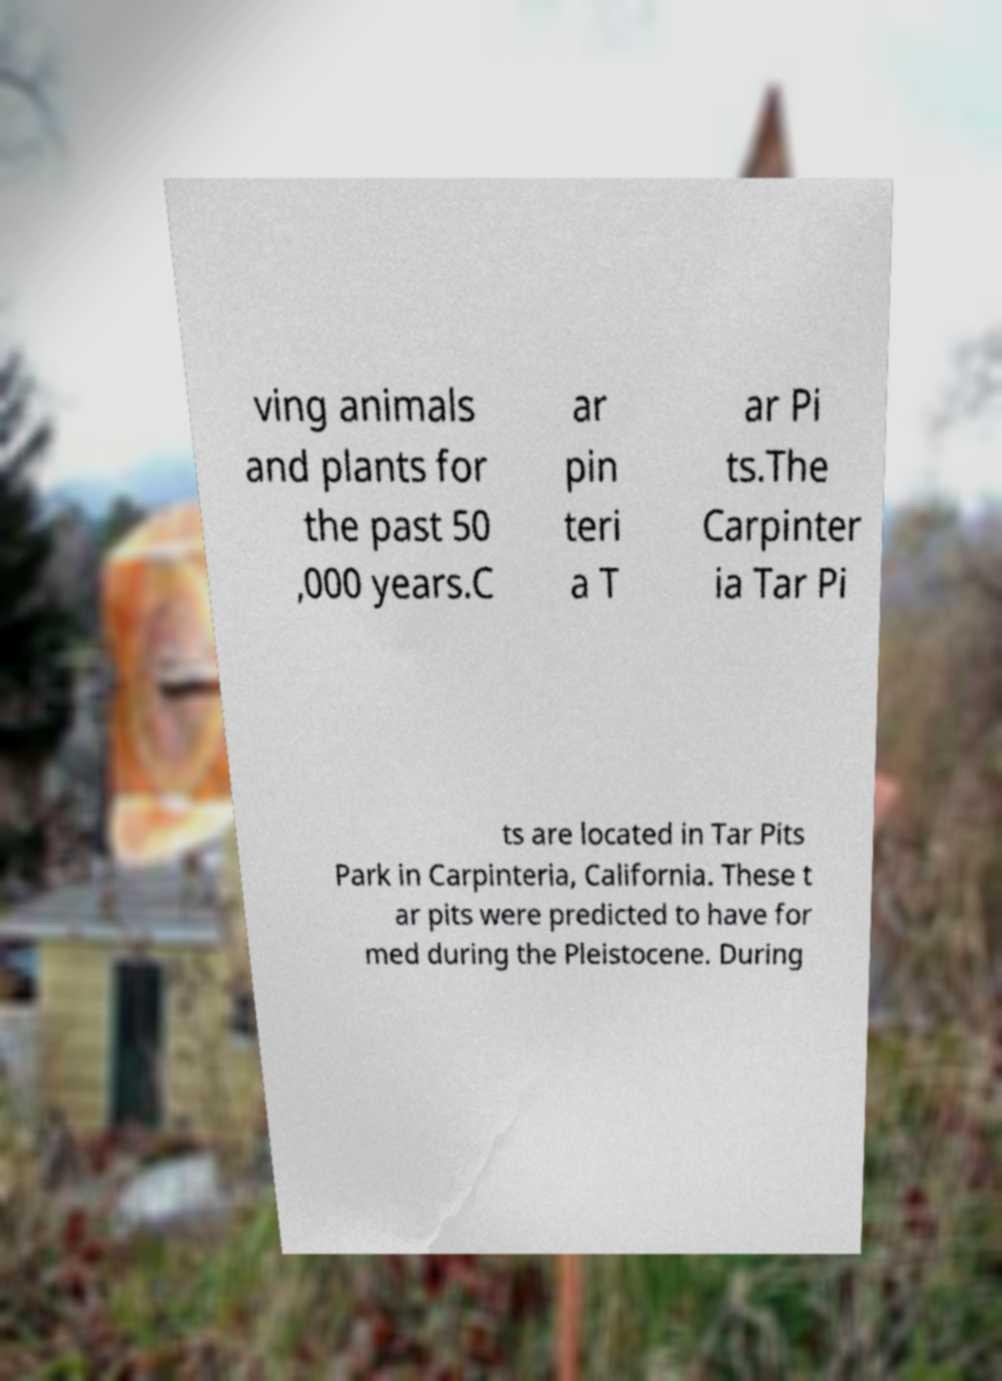Please read and relay the text visible in this image. What does it say? ving animals and plants for the past 50 ,000 years.C ar pin teri a T ar Pi ts.The Carpinter ia Tar Pi ts are located in Tar Pits Park in Carpinteria, California. These t ar pits were predicted to have for med during the Pleistocene. During 